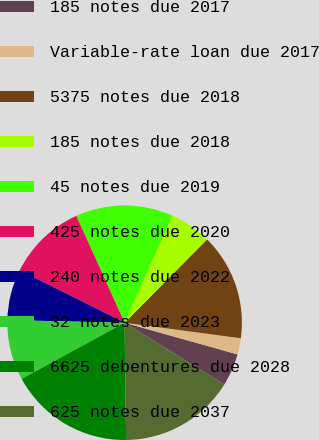<chart> <loc_0><loc_0><loc_500><loc_500><pie_chart><fcel>185 notes due 2017<fcel>Variable-rate loan due 2017<fcel>5375 notes due 2018<fcel>185 notes due 2018<fcel>45 notes due 2019<fcel>425 notes due 2020<fcel>240 notes due 2022<fcel>32 notes due 2023<fcel>6625 debentures due 2028<fcel>625 notes due 2037<nl><fcel>4.48%<fcel>2.24%<fcel>14.69%<fcel>5.76%<fcel>13.42%<fcel>10.86%<fcel>7.03%<fcel>8.31%<fcel>17.25%<fcel>15.97%<nl></chart> 